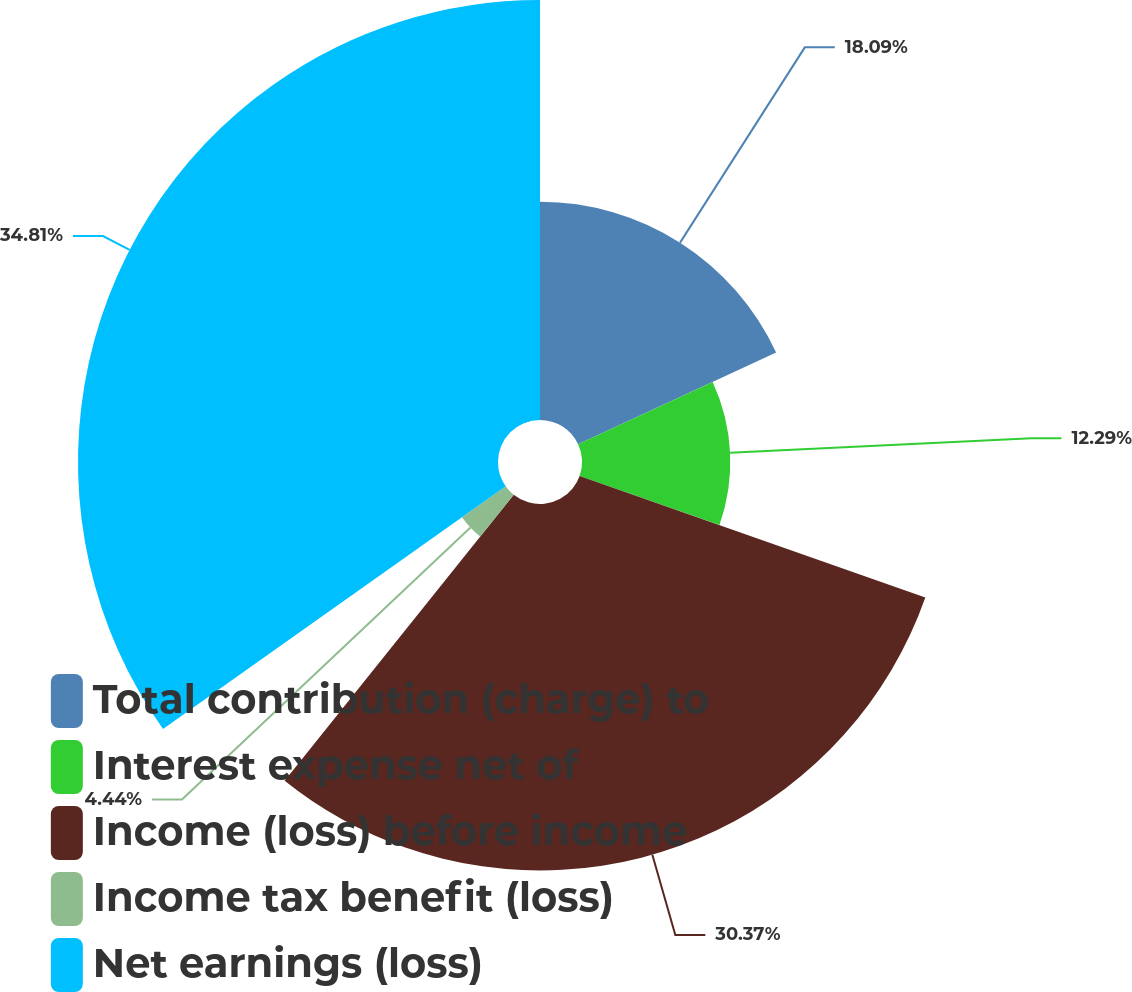Convert chart to OTSL. <chart><loc_0><loc_0><loc_500><loc_500><pie_chart><fcel>Total contribution (charge) to<fcel>Interest expense net of<fcel>Income (loss) before income<fcel>Income tax benefit (loss)<fcel>Net earnings (loss)<nl><fcel>18.09%<fcel>12.29%<fcel>30.37%<fcel>4.44%<fcel>34.81%<nl></chart> 